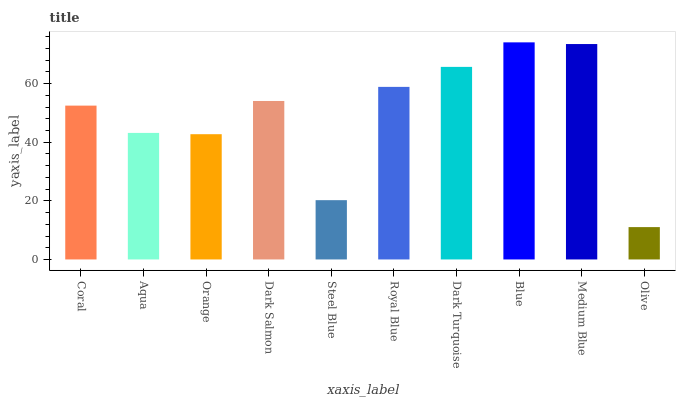Is Olive the minimum?
Answer yes or no. Yes. Is Blue the maximum?
Answer yes or no. Yes. Is Aqua the minimum?
Answer yes or no. No. Is Aqua the maximum?
Answer yes or no. No. Is Coral greater than Aqua?
Answer yes or no. Yes. Is Aqua less than Coral?
Answer yes or no. Yes. Is Aqua greater than Coral?
Answer yes or no. No. Is Coral less than Aqua?
Answer yes or no. No. Is Dark Salmon the high median?
Answer yes or no. Yes. Is Coral the low median?
Answer yes or no. Yes. Is Coral the high median?
Answer yes or no. No. Is Olive the low median?
Answer yes or no. No. 